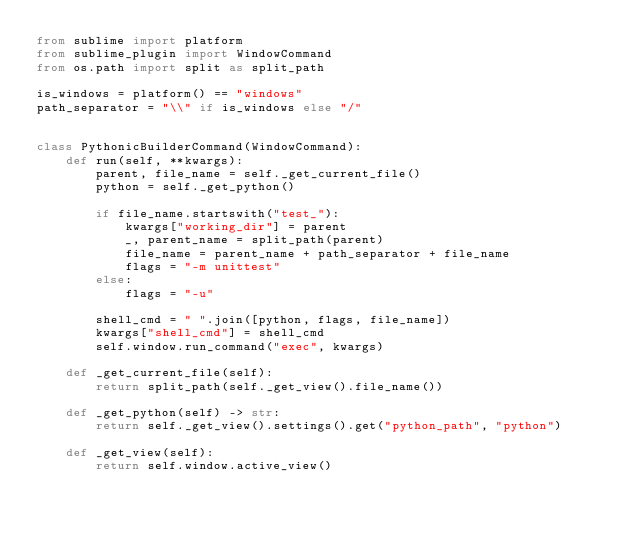<code> <loc_0><loc_0><loc_500><loc_500><_Python_>from sublime import platform
from sublime_plugin import WindowCommand
from os.path import split as split_path

is_windows = platform() == "windows"
path_separator = "\\" if is_windows else "/"


class PythonicBuilderCommand(WindowCommand):
    def run(self, **kwargs):
        parent, file_name = self._get_current_file()
        python = self._get_python()

        if file_name.startswith("test_"):
            kwargs["working_dir"] = parent
            _, parent_name = split_path(parent)
            file_name = parent_name + path_separator + file_name
            flags = "-m unittest"
        else:
            flags = "-u"

        shell_cmd = " ".join([python, flags, file_name])
        kwargs["shell_cmd"] = shell_cmd
        self.window.run_command("exec", kwargs)

    def _get_current_file(self):
        return split_path(self._get_view().file_name())

    def _get_python(self) -> str:
        return self._get_view().settings().get("python_path", "python")

    def _get_view(self):
        return self.window.active_view()
</code> 